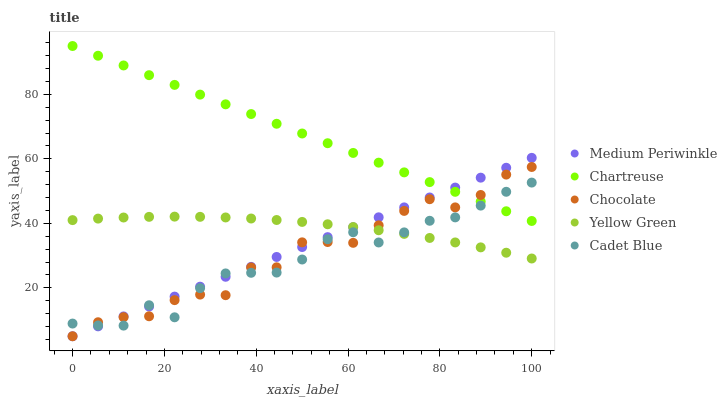Does Cadet Blue have the minimum area under the curve?
Answer yes or no. Yes. Does Chartreuse have the maximum area under the curve?
Answer yes or no. Yes. Does Medium Periwinkle have the minimum area under the curve?
Answer yes or no. No. Does Medium Periwinkle have the maximum area under the curve?
Answer yes or no. No. Is Medium Periwinkle the smoothest?
Answer yes or no. Yes. Is Chocolate the roughest?
Answer yes or no. Yes. Is Cadet Blue the smoothest?
Answer yes or no. No. Is Cadet Blue the roughest?
Answer yes or no. No. Does Medium Periwinkle have the lowest value?
Answer yes or no. Yes. Does Cadet Blue have the lowest value?
Answer yes or no. No. Does Chartreuse have the highest value?
Answer yes or no. Yes. Does Cadet Blue have the highest value?
Answer yes or no. No. Is Yellow Green less than Chartreuse?
Answer yes or no. Yes. Is Chartreuse greater than Yellow Green?
Answer yes or no. Yes. Does Yellow Green intersect Medium Periwinkle?
Answer yes or no. Yes. Is Yellow Green less than Medium Periwinkle?
Answer yes or no. No. Is Yellow Green greater than Medium Periwinkle?
Answer yes or no. No. Does Yellow Green intersect Chartreuse?
Answer yes or no. No. 